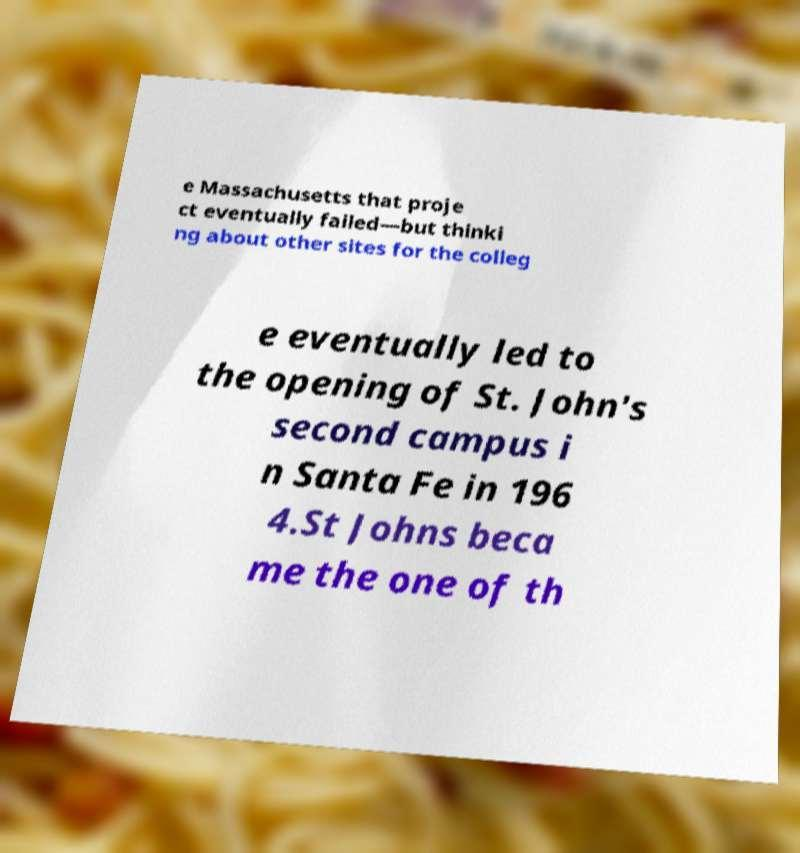Can you accurately transcribe the text from the provided image for me? e Massachusetts that proje ct eventually failed—but thinki ng about other sites for the colleg e eventually led to the opening of St. John's second campus i n Santa Fe in 196 4.St Johns beca me the one of th 